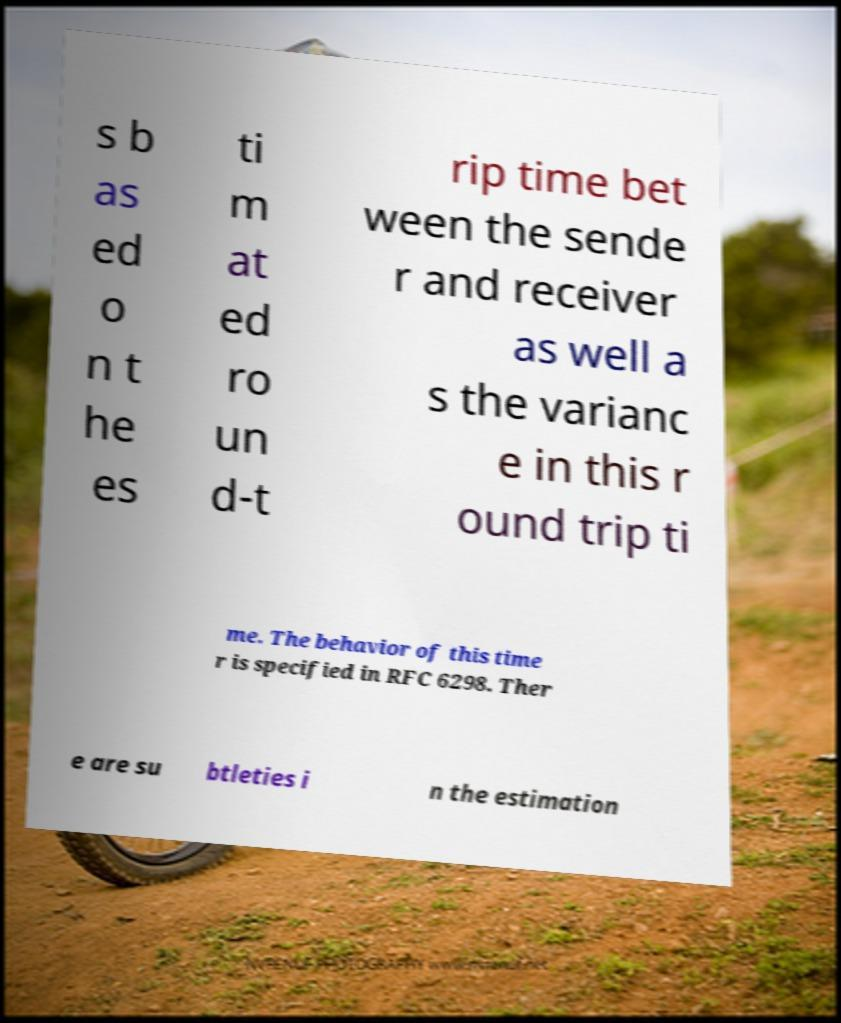Can you read and provide the text displayed in the image?This photo seems to have some interesting text. Can you extract and type it out for me? s b as ed o n t he es ti m at ed ro un d-t rip time bet ween the sende r and receiver as well a s the varianc e in this r ound trip ti me. The behavior of this time r is specified in RFC 6298. Ther e are su btleties i n the estimation 